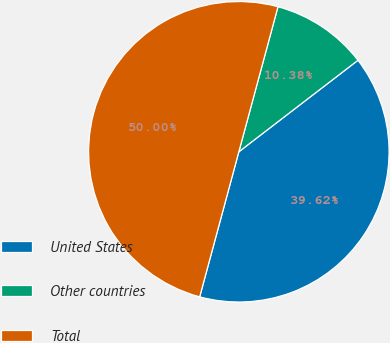Convert chart. <chart><loc_0><loc_0><loc_500><loc_500><pie_chart><fcel>United States<fcel>Other countries<fcel>Total<nl><fcel>39.62%<fcel>10.38%<fcel>50.0%<nl></chart> 